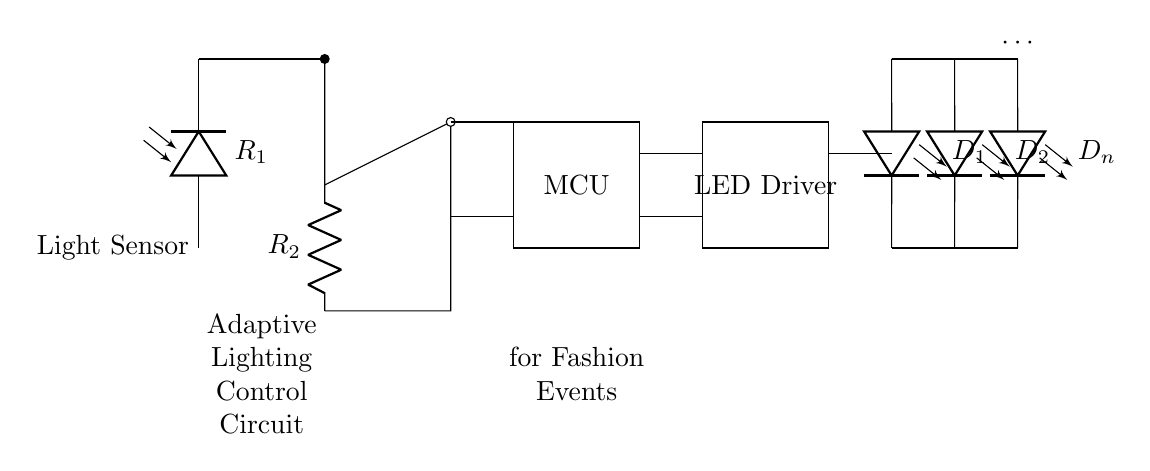What types of components are included in this circuit? The circuit includes a light sensor, an amplifier, a microcontroller, an LED driver, and LED arrays, which are identifiable by their symbols and labels in the diagram.
Answer: light sensor, amplifier, microcontroller, LED driver, LED arrays How many LEDs are represented in the circuit? The circuit shows the use of LEDs ranging from D1 to Dn, where n is not specified but indicates multiple. The "..." suggests a continuation of the LED array.
Answer: n What is the role of the microcontroller in this circuit? The microcontroller (MCU) is responsible for processing signals from the amplifier and controlling the LED driver based on changes in light detected by the light sensor.
Answer: processing signals What is the function of the light sensor? The light sensor detects ambient light levels, which influences the brightness of the LEDs based on the surrounding conditions at the fashion event.
Answer: detecting ambient light In this circuit, how is the amplifier connected to the microcontroller? The amplifier output connects directly to the microcontroller's input, ensuring that the amplified signal from the light sensor is sent for processing.
Answer: directly What is the purpose of the LED driver in this circuit? The LED driver regulates the current to the LEDs, allowing for efficient brightness control as determined by the microcontroller's outputs based on light sensor readings.
Answer: brightness control 